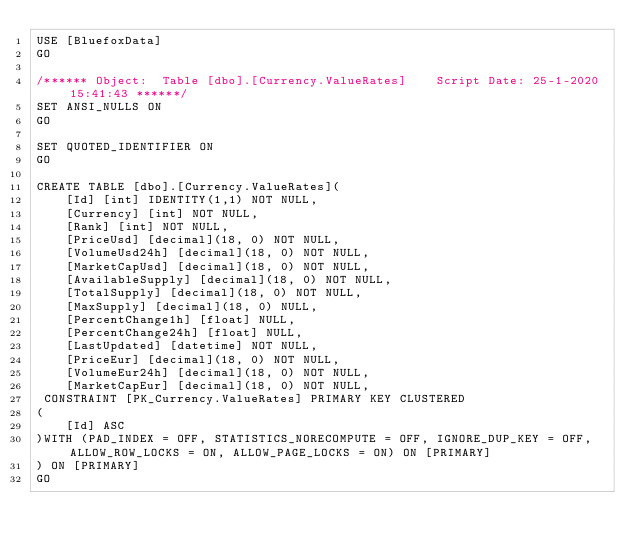<code> <loc_0><loc_0><loc_500><loc_500><_SQL_>USE [BluefoxData]
GO

/****** Object:  Table [dbo].[Currency.ValueRates]    Script Date: 25-1-2020 15:41:43 ******/
SET ANSI_NULLS ON
GO

SET QUOTED_IDENTIFIER ON
GO

CREATE TABLE [dbo].[Currency.ValueRates](
	[Id] [int] IDENTITY(1,1) NOT NULL,
	[Currency] [int] NOT NULL,
	[Rank] [int] NOT NULL,
	[PriceUsd] [decimal](18, 0) NOT NULL,
	[VolumeUsd24h] [decimal](18, 0) NOT NULL,
	[MarketCapUsd] [decimal](18, 0) NOT NULL,
	[AvailableSupply] [decimal](18, 0) NOT NULL,
	[TotalSupply] [decimal](18, 0) NOT NULL,
	[MaxSupply] [decimal](18, 0) NULL,
	[PercentChange1h] [float] NULL,
	[PercentChange24h] [float] NULL,
	[LastUpdated] [datetime] NOT NULL,
	[PriceEur] [decimal](18, 0) NOT NULL,
	[VolumeEur24h] [decimal](18, 0) NOT NULL,
	[MarketCapEur] [decimal](18, 0) NOT NULL,
 CONSTRAINT [PK_Currency.ValueRates] PRIMARY KEY CLUSTERED 
(
	[Id] ASC
)WITH (PAD_INDEX = OFF, STATISTICS_NORECOMPUTE = OFF, IGNORE_DUP_KEY = OFF, ALLOW_ROW_LOCKS = ON, ALLOW_PAGE_LOCKS = ON) ON [PRIMARY]
) ON [PRIMARY]
GO

</code> 